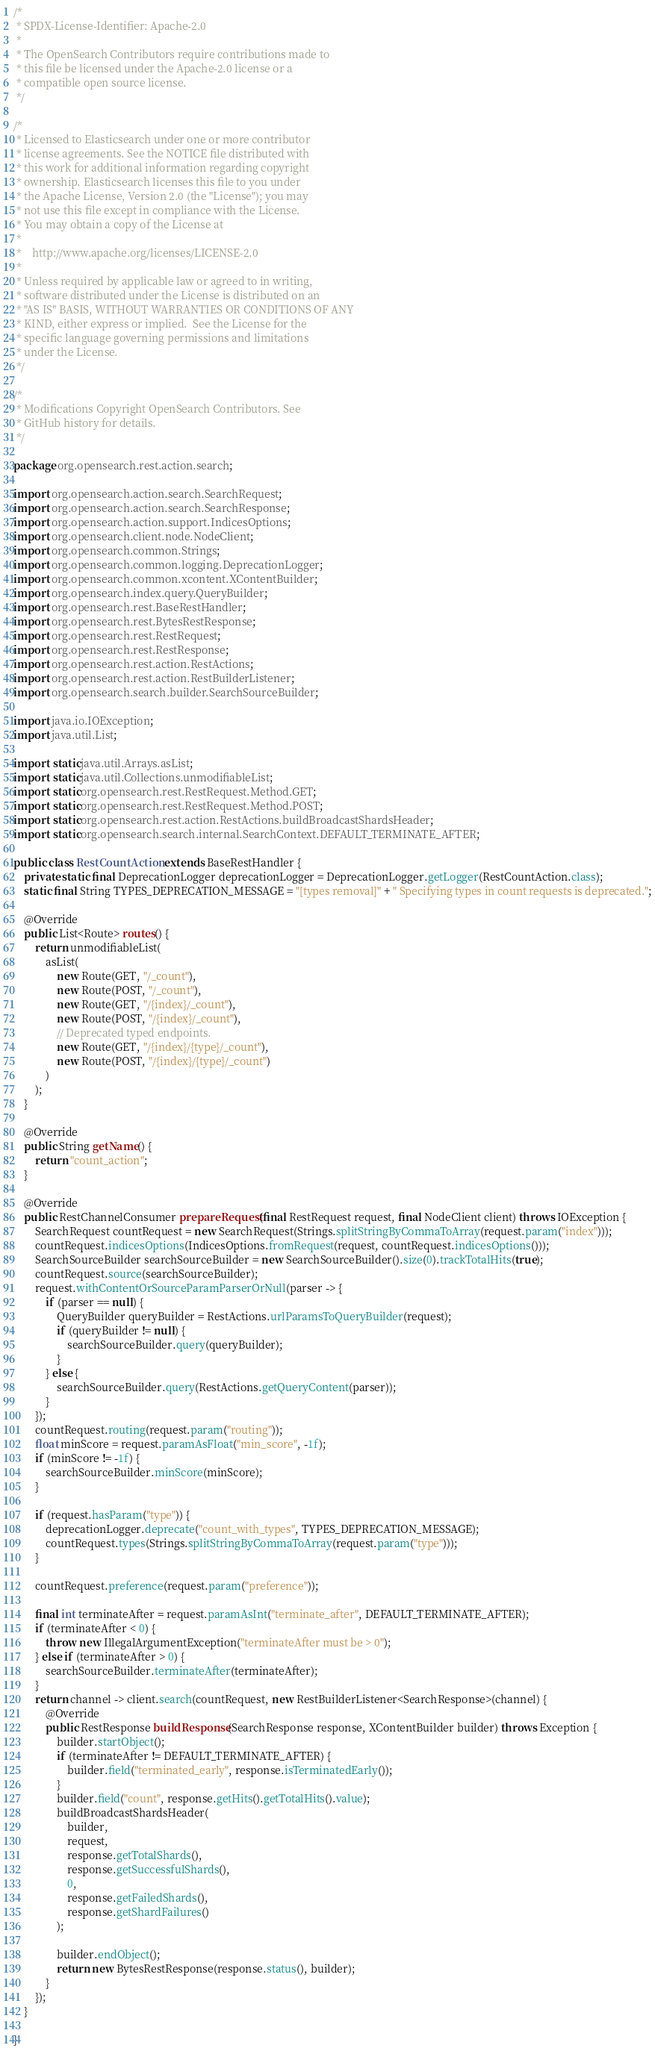<code> <loc_0><loc_0><loc_500><loc_500><_Java_>/*
 * SPDX-License-Identifier: Apache-2.0
 *
 * The OpenSearch Contributors require contributions made to
 * this file be licensed under the Apache-2.0 license or a
 * compatible open source license.
 */

/*
 * Licensed to Elasticsearch under one or more contributor
 * license agreements. See the NOTICE file distributed with
 * this work for additional information regarding copyright
 * ownership. Elasticsearch licenses this file to you under
 * the Apache License, Version 2.0 (the "License"); you may
 * not use this file except in compliance with the License.
 * You may obtain a copy of the License at
 *
 *    http://www.apache.org/licenses/LICENSE-2.0
 *
 * Unless required by applicable law or agreed to in writing,
 * software distributed under the License is distributed on an
 * "AS IS" BASIS, WITHOUT WARRANTIES OR CONDITIONS OF ANY
 * KIND, either express or implied.  See the License for the
 * specific language governing permissions and limitations
 * under the License.
 */

/*
 * Modifications Copyright OpenSearch Contributors. See
 * GitHub history for details.
 */

package org.opensearch.rest.action.search;

import org.opensearch.action.search.SearchRequest;
import org.opensearch.action.search.SearchResponse;
import org.opensearch.action.support.IndicesOptions;
import org.opensearch.client.node.NodeClient;
import org.opensearch.common.Strings;
import org.opensearch.common.logging.DeprecationLogger;
import org.opensearch.common.xcontent.XContentBuilder;
import org.opensearch.index.query.QueryBuilder;
import org.opensearch.rest.BaseRestHandler;
import org.opensearch.rest.BytesRestResponse;
import org.opensearch.rest.RestRequest;
import org.opensearch.rest.RestResponse;
import org.opensearch.rest.action.RestActions;
import org.opensearch.rest.action.RestBuilderListener;
import org.opensearch.search.builder.SearchSourceBuilder;

import java.io.IOException;
import java.util.List;

import static java.util.Arrays.asList;
import static java.util.Collections.unmodifiableList;
import static org.opensearch.rest.RestRequest.Method.GET;
import static org.opensearch.rest.RestRequest.Method.POST;
import static org.opensearch.rest.action.RestActions.buildBroadcastShardsHeader;
import static org.opensearch.search.internal.SearchContext.DEFAULT_TERMINATE_AFTER;

public class RestCountAction extends BaseRestHandler {
    private static final DeprecationLogger deprecationLogger = DeprecationLogger.getLogger(RestCountAction.class);
    static final String TYPES_DEPRECATION_MESSAGE = "[types removal]" + " Specifying types in count requests is deprecated.";

    @Override
    public List<Route> routes() {
        return unmodifiableList(
            asList(
                new Route(GET, "/_count"),
                new Route(POST, "/_count"),
                new Route(GET, "/{index}/_count"),
                new Route(POST, "/{index}/_count"),
                // Deprecated typed endpoints.
                new Route(GET, "/{index}/{type}/_count"),
                new Route(POST, "/{index}/{type}/_count")
            )
        );
    }

    @Override
    public String getName() {
        return "count_action";
    }

    @Override
    public RestChannelConsumer prepareRequest(final RestRequest request, final NodeClient client) throws IOException {
        SearchRequest countRequest = new SearchRequest(Strings.splitStringByCommaToArray(request.param("index")));
        countRequest.indicesOptions(IndicesOptions.fromRequest(request, countRequest.indicesOptions()));
        SearchSourceBuilder searchSourceBuilder = new SearchSourceBuilder().size(0).trackTotalHits(true);
        countRequest.source(searchSourceBuilder);
        request.withContentOrSourceParamParserOrNull(parser -> {
            if (parser == null) {
                QueryBuilder queryBuilder = RestActions.urlParamsToQueryBuilder(request);
                if (queryBuilder != null) {
                    searchSourceBuilder.query(queryBuilder);
                }
            } else {
                searchSourceBuilder.query(RestActions.getQueryContent(parser));
            }
        });
        countRequest.routing(request.param("routing"));
        float minScore = request.paramAsFloat("min_score", -1f);
        if (minScore != -1f) {
            searchSourceBuilder.minScore(minScore);
        }

        if (request.hasParam("type")) {
            deprecationLogger.deprecate("count_with_types", TYPES_DEPRECATION_MESSAGE);
            countRequest.types(Strings.splitStringByCommaToArray(request.param("type")));
        }

        countRequest.preference(request.param("preference"));

        final int terminateAfter = request.paramAsInt("terminate_after", DEFAULT_TERMINATE_AFTER);
        if (terminateAfter < 0) {
            throw new IllegalArgumentException("terminateAfter must be > 0");
        } else if (terminateAfter > 0) {
            searchSourceBuilder.terminateAfter(terminateAfter);
        }
        return channel -> client.search(countRequest, new RestBuilderListener<SearchResponse>(channel) {
            @Override
            public RestResponse buildResponse(SearchResponse response, XContentBuilder builder) throws Exception {
                builder.startObject();
                if (terminateAfter != DEFAULT_TERMINATE_AFTER) {
                    builder.field("terminated_early", response.isTerminatedEarly());
                }
                builder.field("count", response.getHits().getTotalHits().value);
                buildBroadcastShardsHeader(
                    builder,
                    request,
                    response.getTotalShards(),
                    response.getSuccessfulShards(),
                    0,
                    response.getFailedShards(),
                    response.getShardFailures()
                );

                builder.endObject();
                return new BytesRestResponse(response.status(), builder);
            }
        });
    }

}
</code> 